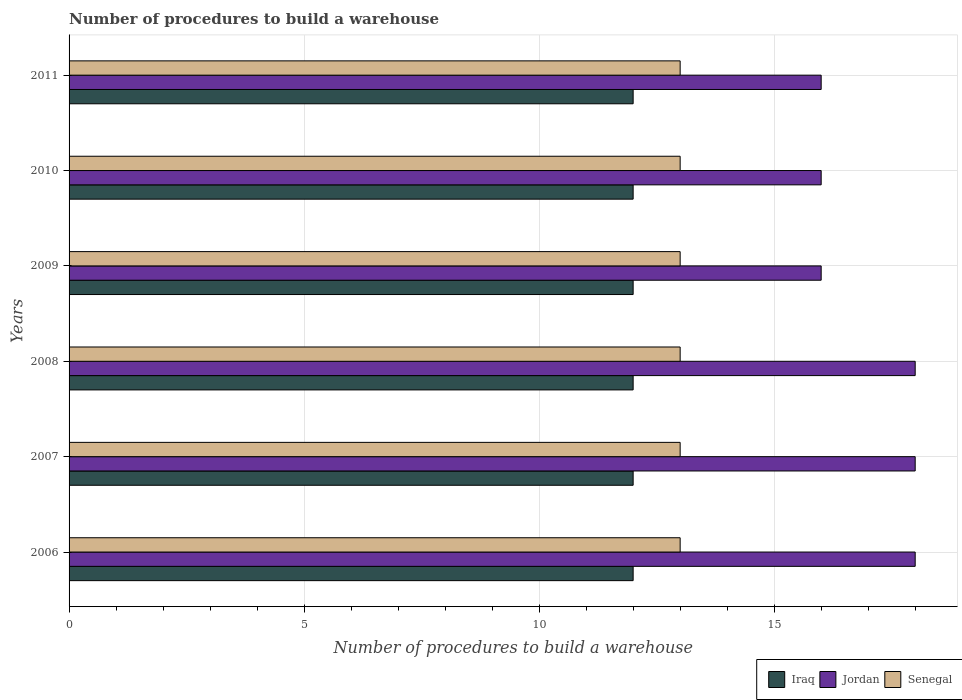How many different coloured bars are there?
Make the answer very short. 3. Are the number of bars per tick equal to the number of legend labels?
Provide a short and direct response. Yes. How many bars are there on the 1st tick from the top?
Provide a succinct answer. 3. What is the label of the 1st group of bars from the top?
Give a very brief answer. 2011. What is the number of procedures to build a warehouse in in Senegal in 2006?
Your answer should be very brief. 13. Across all years, what is the maximum number of procedures to build a warehouse in in Iraq?
Make the answer very short. 12. Across all years, what is the minimum number of procedures to build a warehouse in in Senegal?
Keep it short and to the point. 13. In which year was the number of procedures to build a warehouse in in Iraq minimum?
Make the answer very short. 2006. What is the total number of procedures to build a warehouse in in Iraq in the graph?
Your answer should be very brief. 72. What is the difference between the number of procedures to build a warehouse in in Jordan in 2007 and that in 2010?
Offer a very short reply. 2. What is the difference between the number of procedures to build a warehouse in in Senegal in 2011 and the number of procedures to build a warehouse in in Iraq in 2008?
Provide a succinct answer. 1. What is the average number of procedures to build a warehouse in in Iraq per year?
Keep it short and to the point. 12. In how many years, is the number of procedures to build a warehouse in in Iraq greater than 15 ?
Ensure brevity in your answer.  0. What is the ratio of the number of procedures to build a warehouse in in Senegal in 2008 to that in 2011?
Your answer should be very brief. 1. Is the difference between the number of procedures to build a warehouse in in Jordan in 2008 and 2009 greater than the difference between the number of procedures to build a warehouse in in Iraq in 2008 and 2009?
Ensure brevity in your answer.  Yes. What is the difference between the highest and the lowest number of procedures to build a warehouse in in Jordan?
Keep it short and to the point. 2. Is the sum of the number of procedures to build a warehouse in in Senegal in 2008 and 2011 greater than the maximum number of procedures to build a warehouse in in Jordan across all years?
Provide a short and direct response. Yes. What does the 3rd bar from the top in 2009 represents?
Make the answer very short. Iraq. What does the 2nd bar from the bottom in 2009 represents?
Provide a succinct answer. Jordan. Is it the case that in every year, the sum of the number of procedures to build a warehouse in in Senegal and number of procedures to build a warehouse in in Jordan is greater than the number of procedures to build a warehouse in in Iraq?
Ensure brevity in your answer.  Yes. How many bars are there?
Your answer should be very brief. 18. Are all the bars in the graph horizontal?
Keep it short and to the point. Yes. How many years are there in the graph?
Offer a very short reply. 6. Are the values on the major ticks of X-axis written in scientific E-notation?
Provide a short and direct response. No. Where does the legend appear in the graph?
Make the answer very short. Bottom right. How many legend labels are there?
Offer a terse response. 3. How are the legend labels stacked?
Your answer should be very brief. Horizontal. What is the title of the graph?
Provide a short and direct response. Number of procedures to build a warehouse. What is the label or title of the X-axis?
Offer a very short reply. Number of procedures to build a warehouse. What is the Number of procedures to build a warehouse of Jordan in 2008?
Ensure brevity in your answer.  18. What is the Number of procedures to build a warehouse of Iraq in 2009?
Make the answer very short. 12. What is the Number of procedures to build a warehouse of Jordan in 2009?
Give a very brief answer. 16. What is the Number of procedures to build a warehouse of Senegal in 2009?
Your answer should be compact. 13. What is the Number of procedures to build a warehouse in Jordan in 2010?
Ensure brevity in your answer.  16. What is the Number of procedures to build a warehouse in Senegal in 2010?
Keep it short and to the point. 13. Across all years, what is the maximum Number of procedures to build a warehouse in Senegal?
Give a very brief answer. 13. Across all years, what is the minimum Number of procedures to build a warehouse of Jordan?
Offer a terse response. 16. Across all years, what is the minimum Number of procedures to build a warehouse in Senegal?
Provide a short and direct response. 13. What is the total Number of procedures to build a warehouse of Iraq in the graph?
Provide a succinct answer. 72. What is the total Number of procedures to build a warehouse of Jordan in the graph?
Keep it short and to the point. 102. What is the difference between the Number of procedures to build a warehouse of Iraq in 2006 and that in 2007?
Offer a very short reply. 0. What is the difference between the Number of procedures to build a warehouse of Senegal in 2006 and that in 2007?
Your response must be concise. 0. What is the difference between the Number of procedures to build a warehouse in Iraq in 2006 and that in 2008?
Provide a succinct answer. 0. What is the difference between the Number of procedures to build a warehouse in Iraq in 2006 and that in 2009?
Offer a very short reply. 0. What is the difference between the Number of procedures to build a warehouse of Senegal in 2006 and that in 2011?
Keep it short and to the point. 0. What is the difference between the Number of procedures to build a warehouse of Iraq in 2007 and that in 2008?
Offer a very short reply. 0. What is the difference between the Number of procedures to build a warehouse of Senegal in 2007 and that in 2011?
Give a very brief answer. 0. What is the difference between the Number of procedures to build a warehouse of Iraq in 2008 and that in 2009?
Ensure brevity in your answer.  0. What is the difference between the Number of procedures to build a warehouse of Senegal in 2008 and that in 2009?
Give a very brief answer. 0. What is the difference between the Number of procedures to build a warehouse of Senegal in 2008 and that in 2010?
Make the answer very short. 0. What is the difference between the Number of procedures to build a warehouse of Iraq in 2009 and that in 2010?
Your answer should be very brief. 0. What is the difference between the Number of procedures to build a warehouse of Jordan in 2009 and that in 2010?
Your response must be concise. 0. What is the difference between the Number of procedures to build a warehouse of Senegal in 2009 and that in 2010?
Offer a very short reply. 0. What is the difference between the Number of procedures to build a warehouse of Iraq in 2009 and that in 2011?
Keep it short and to the point. 0. What is the difference between the Number of procedures to build a warehouse in Jordan in 2009 and that in 2011?
Keep it short and to the point. 0. What is the difference between the Number of procedures to build a warehouse in Senegal in 2009 and that in 2011?
Your response must be concise. 0. What is the difference between the Number of procedures to build a warehouse in Iraq in 2006 and the Number of procedures to build a warehouse in Senegal in 2008?
Ensure brevity in your answer.  -1. What is the difference between the Number of procedures to build a warehouse of Iraq in 2006 and the Number of procedures to build a warehouse of Jordan in 2009?
Make the answer very short. -4. What is the difference between the Number of procedures to build a warehouse of Jordan in 2006 and the Number of procedures to build a warehouse of Senegal in 2009?
Provide a succinct answer. 5. What is the difference between the Number of procedures to build a warehouse of Iraq in 2006 and the Number of procedures to build a warehouse of Jordan in 2010?
Ensure brevity in your answer.  -4. What is the difference between the Number of procedures to build a warehouse of Iraq in 2006 and the Number of procedures to build a warehouse of Senegal in 2010?
Your answer should be compact. -1. What is the difference between the Number of procedures to build a warehouse in Jordan in 2006 and the Number of procedures to build a warehouse in Senegal in 2010?
Keep it short and to the point. 5. What is the difference between the Number of procedures to build a warehouse in Iraq in 2006 and the Number of procedures to build a warehouse in Jordan in 2011?
Provide a succinct answer. -4. What is the difference between the Number of procedures to build a warehouse in Iraq in 2006 and the Number of procedures to build a warehouse in Senegal in 2011?
Provide a succinct answer. -1. What is the difference between the Number of procedures to build a warehouse in Jordan in 2006 and the Number of procedures to build a warehouse in Senegal in 2011?
Make the answer very short. 5. What is the difference between the Number of procedures to build a warehouse in Iraq in 2007 and the Number of procedures to build a warehouse in Jordan in 2008?
Make the answer very short. -6. What is the difference between the Number of procedures to build a warehouse in Iraq in 2007 and the Number of procedures to build a warehouse in Senegal in 2008?
Ensure brevity in your answer.  -1. What is the difference between the Number of procedures to build a warehouse of Jordan in 2007 and the Number of procedures to build a warehouse of Senegal in 2008?
Your answer should be compact. 5. What is the difference between the Number of procedures to build a warehouse in Iraq in 2007 and the Number of procedures to build a warehouse in Senegal in 2009?
Ensure brevity in your answer.  -1. What is the difference between the Number of procedures to build a warehouse of Iraq in 2007 and the Number of procedures to build a warehouse of Jordan in 2010?
Offer a terse response. -4. What is the difference between the Number of procedures to build a warehouse of Iraq in 2007 and the Number of procedures to build a warehouse of Senegal in 2010?
Offer a very short reply. -1. What is the difference between the Number of procedures to build a warehouse in Iraq in 2007 and the Number of procedures to build a warehouse in Jordan in 2011?
Your answer should be compact. -4. What is the difference between the Number of procedures to build a warehouse in Iraq in 2007 and the Number of procedures to build a warehouse in Senegal in 2011?
Make the answer very short. -1. What is the difference between the Number of procedures to build a warehouse in Jordan in 2007 and the Number of procedures to build a warehouse in Senegal in 2011?
Your answer should be very brief. 5. What is the difference between the Number of procedures to build a warehouse in Iraq in 2008 and the Number of procedures to build a warehouse in Jordan in 2009?
Keep it short and to the point. -4. What is the difference between the Number of procedures to build a warehouse of Iraq in 2008 and the Number of procedures to build a warehouse of Senegal in 2009?
Keep it short and to the point. -1. What is the difference between the Number of procedures to build a warehouse in Jordan in 2008 and the Number of procedures to build a warehouse in Senegal in 2009?
Give a very brief answer. 5. What is the difference between the Number of procedures to build a warehouse in Iraq in 2008 and the Number of procedures to build a warehouse in Jordan in 2010?
Ensure brevity in your answer.  -4. What is the difference between the Number of procedures to build a warehouse of Jordan in 2008 and the Number of procedures to build a warehouse of Senegal in 2011?
Your answer should be compact. 5. What is the difference between the Number of procedures to build a warehouse of Iraq in 2009 and the Number of procedures to build a warehouse of Jordan in 2010?
Provide a succinct answer. -4. What is the difference between the Number of procedures to build a warehouse in Iraq in 2009 and the Number of procedures to build a warehouse in Senegal in 2010?
Ensure brevity in your answer.  -1. What is the difference between the Number of procedures to build a warehouse in Jordan in 2009 and the Number of procedures to build a warehouse in Senegal in 2010?
Your answer should be very brief. 3. What is the difference between the Number of procedures to build a warehouse of Iraq in 2009 and the Number of procedures to build a warehouse of Senegal in 2011?
Ensure brevity in your answer.  -1. What is the difference between the Number of procedures to build a warehouse in Jordan in 2009 and the Number of procedures to build a warehouse in Senegal in 2011?
Your response must be concise. 3. What is the difference between the Number of procedures to build a warehouse in Iraq in 2010 and the Number of procedures to build a warehouse in Jordan in 2011?
Provide a short and direct response. -4. What is the difference between the Number of procedures to build a warehouse in Iraq in 2010 and the Number of procedures to build a warehouse in Senegal in 2011?
Offer a very short reply. -1. What is the difference between the Number of procedures to build a warehouse of Jordan in 2010 and the Number of procedures to build a warehouse of Senegal in 2011?
Offer a very short reply. 3. What is the average Number of procedures to build a warehouse in Iraq per year?
Your answer should be very brief. 12. What is the average Number of procedures to build a warehouse in Senegal per year?
Offer a very short reply. 13. In the year 2006, what is the difference between the Number of procedures to build a warehouse in Iraq and Number of procedures to build a warehouse in Senegal?
Offer a terse response. -1. In the year 2007, what is the difference between the Number of procedures to build a warehouse in Iraq and Number of procedures to build a warehouse in Senegal?
Offer a terse response. -1. In the year 2007, what is the difference between the Number of procedures to build a warehouse in Jordan and Number of procedures to build a warehouse in Senegal?
Keep it short and to the point. 5. In the year 2008, what is the difference between the Number of procedures to build a warehouse of Iraq and Number of procedures to build a warehouse of Senegal?
Your answer should be very brief. -1. In the year 2009, what is the difference between the Number of procedures to build a warehouse of Iraq and Number of procedures to build a warehouse of Senegal?
Make the answer very short. -1. In the year 2011, what is the difference between the Number of procedures to build a warehouse of Iraq and Number of procedures to build a warehouse of Senegal?
Make the answer very short. -1. What is the ratio of the Number of procedures to build a warehouse of Jordan in 2006 to that in 2008?
Provide a short and direct response. 1. What is the ratio of the Number of procedures to build a warehouse of Senegal in 2006 to that in 2008?
Keep it short and to the point. 1. What is the ratio of the Number of procedures to build a warehouse of Jordan in 2006 to that in 2009?
Provide a succinct answer. 1.12. What is the ratio of the Number of procedures to build a warehouse of Jordan in 2006 to that in 2010?
Offer a terse response. 1.12. What is the ratio of the Number of procedures to build a warehouse in Senegal in 2006 to that in 2010?
Your answer should be very brief. 1. What is the ratio of the Number of procedures to build a warehouse in Iraq in 2006 to that in 2011?
Your response must be concise. 1. What is the ratio of the Number of procedures to build a warehouse of Senegal in 2006 to that in 2011?
Offer a very short reply. 1. What is the ratio of the Number of procedures to build a warehouse in Jordan in 2007 to that in 2010?
Provide a short and direct response. 1.12. What is the ratio of the Number of procedures to build a warehouse in Senegal in 2007 to that in 2010?
Provide a short and direct response. 1. What is the ratio of the Number of procedures to build a warehouse of Iraq in 2007 to that in 2011?
Your answer should be very brief. 1. What is the ratio of the Number of procedures to build a warehouse of Senegal in 2007 to that in 2011?
Your answer should be very brief. 1. What is the ratio of the Number of procedures to build a warehouse of Iraq in 2008 to that in 2009?
Your answer should be very brief. 1. What is the ratio of the Number of procedures to build a warehouse in Jordan in 2008 to that in 2009?
Keep it short and to the point. 1.12. What is the ratio of the Number of procedures to build a warehouse of Senegal in 2008 to that in 2009?
Ensure brevity in your answer.  1. What is the ratio of the Number of procedures to build a warehouse of Senegal in 2008 to that in 2010?
Give a very brief answer. 1. What is the ratio of the Number of procedures to build a warehouse of Iraq in 2008 to that in 2011?
Offer a very short reply. 1. What is the ratio of the Number of procedures to build a warehouse of Senegal in 2008 to that in 2011?
Ensure brevity in your answer.  1. What is the ratio of the Number of procedures to build a warehouse of Iraq in 2009 to that in 2010?
Your answer should be very brief. 1. What is the ratio of the Number of procedures to build a warehouse of Jordan in 2009 to that in 2010?
Your response must be concise. 1. What is the ratio of the Number of procedures to build a warehouse in Senegal in 2009 to that in 2010?
Your response must be concise. 1. What is the difference between the highest and the second highest Number of procedures to build a warehouse in Iraq?
Provide a short and direct response. 0. What is the difference between the highest and the lowest Number of procedures to build a warehouse in Jordan?
Your answer should be very brief. 2. 